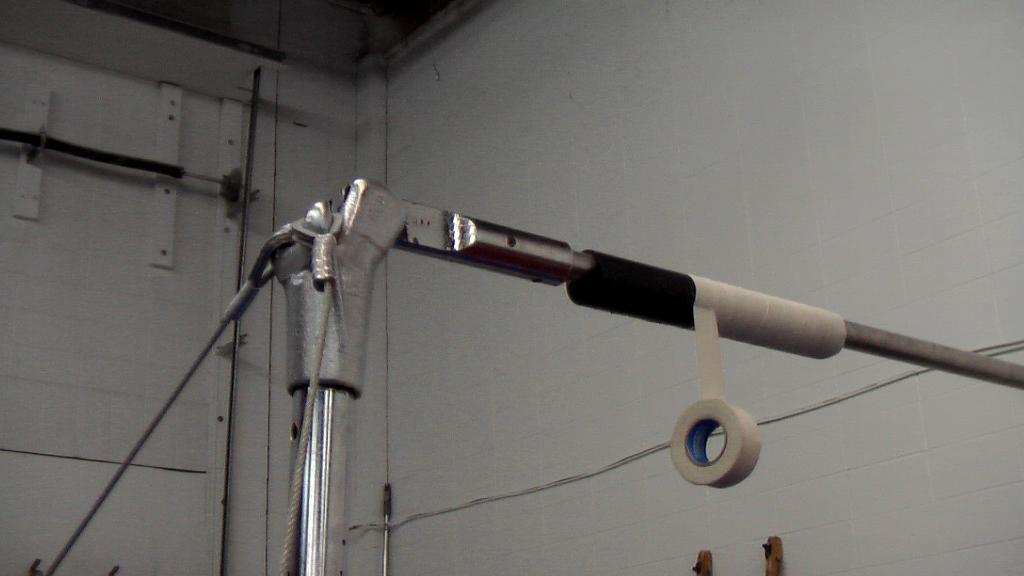How would you summarize this image in a sentence or two? In this picture we can see a rope and a tape on the stand. We can see a few objects and a wall is visible in the background. 